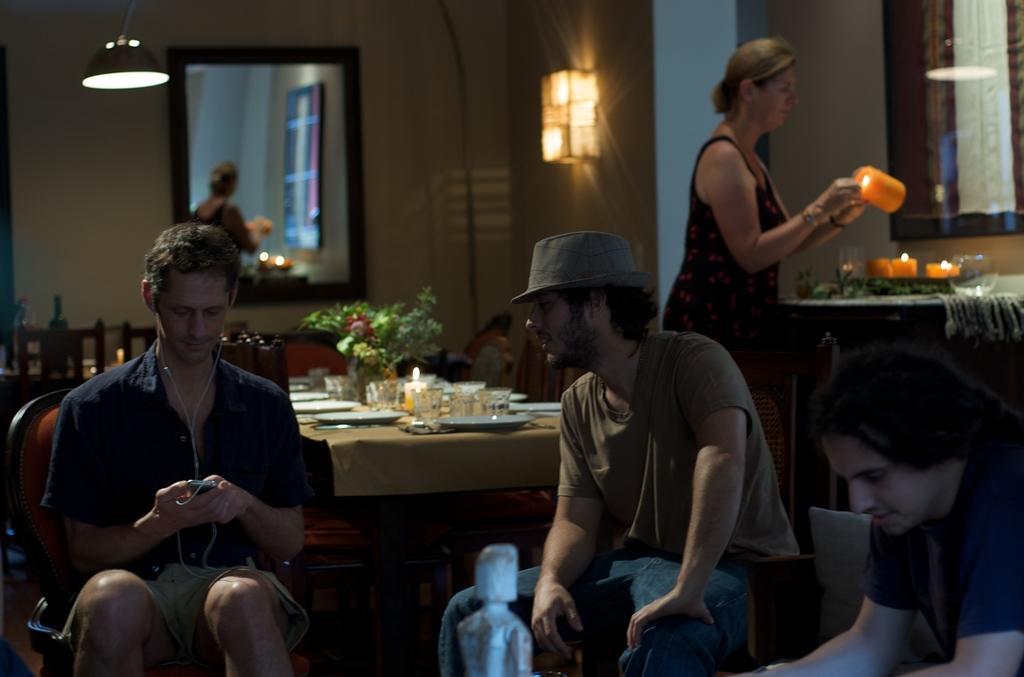Can you describe this image briefly? In this image there are four people. Three are sitting and one standing and holding a candle. There are glasses, plates, candle and a flower vase on the table. At the top there is a light and at the back there on the wall there is a mirror. 